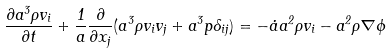<formula> <loc_0><loc_0><loc_500><loc_500>\frac { \partial a ^ { 3 } \rho v _ { i } } { \partial t } + \frac { 1 } { a } \frac { \partial } { \partial x _ { j } } ( a ^ { 3 } \rho v _ { i } v _ { j } + a ^ { 3 } p \delta _ { i j } ) = - \dot { a } a ^ { 2 } \rho v _ { i } - a ^ { 2 } \rho \nabla \phi</formula> 